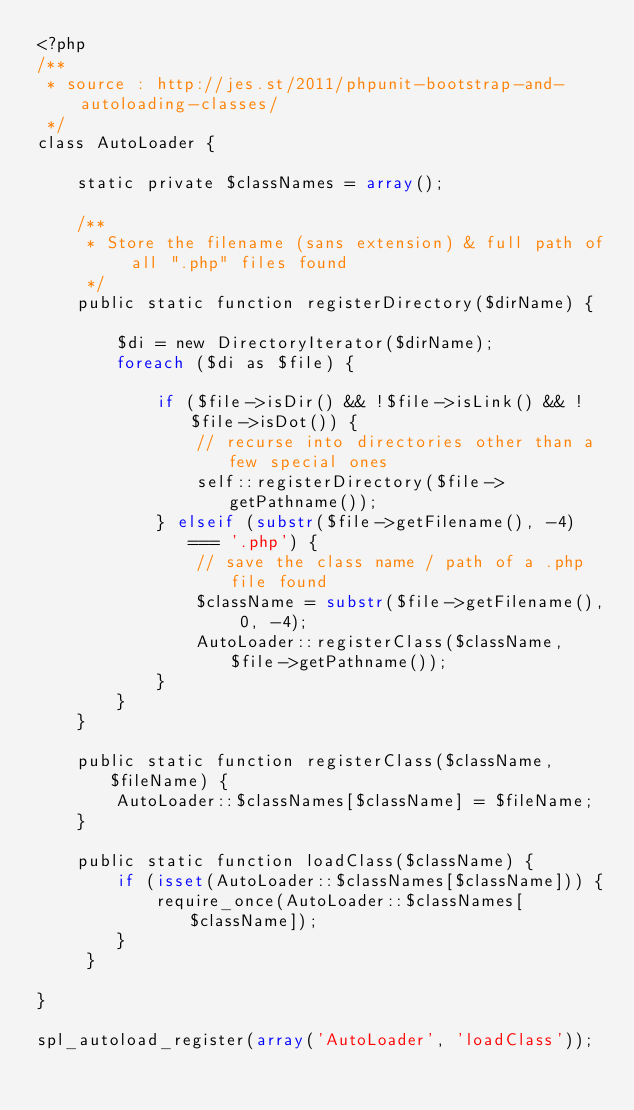Convert code to text. <code><loc_0><loc_0><loc_500><loc_500><_PHP_><?php
/**
 * source : http://jes.st/2011/phpunit-bootstrap-and-autoloading-classes/
 */
class AutoLoader {
 
    static private $classNames = array();
 
    /**
     * Store the filename (sans extension) & full path of all ".php" files found
     */
    public static function registerDirectory($dirName) {
 
        $di = new DirectoryIterator($dirName);
        foreach ($di as $file) {
 
            if ($file->isDir() && !$file->isLink() && !$file->isDot()) {
                // recurse into directories other than a few special ones
                self::registerDirectory($file->getPathname());
            } elseif (substr($file->getFilename(), -4) === '.php') {
                // save the class name / path of a .php file found
                $className = substr($file->getFilename(), 0, -4);
                AutoLoader::registerClass($className, $file->getPathname());
            }
        }
    }
 
    public static function registerClass($className, $fileName) {
        AutoLoader::$classNames[$className] = $fileName;
    }
 
    public static function loadClass($className) {
        if (isset(AutoLoader::$classNames[$className])) {
            require_once(AutoLoader::$classNames[$className]);
        }
     }
 
}
 
spl_autoload_register(array('AutoLoader', 'loadClass'));</code> 